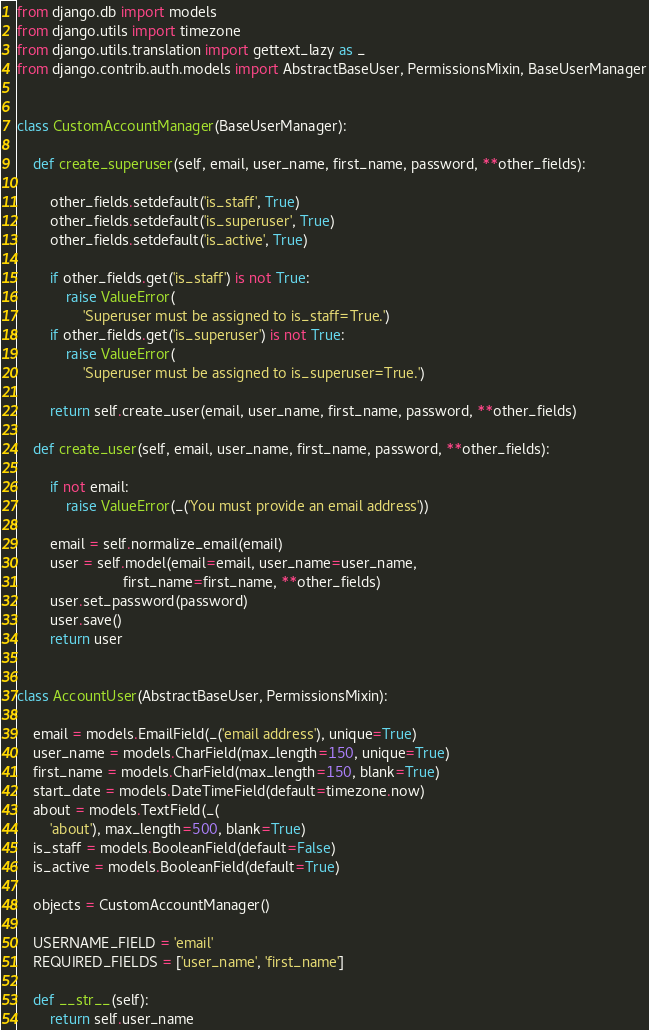<code> <loc_0><loc_0><loc_500><loc_500><_Python_>from django.db import models
from django.utils import timezone
from django.utils.translation import gettext_lazy as _
from django.contrib.auth.models import AbstractBaseUser, PermissionsMixin, BaseUserManager


class CustomAccountManager(BaseUserManager):

    def create_superuser(self, email, user_name, first_name, password, **other_fields):

        other_fields.setdefault('is_staff', True)
        other_fields.setdefault('is_superuser', True)
        other_fields.setdefault('is_active', True)

        if other_fields.get('is_staff') is not True:
            raise ValueError(
                'Superuser must be assigned to is_staff=True.')
        if other_fields.get('is_superuser') is not True:
            raise ValueError(
                'Superuser must be assigned to is_superuser=True.')

        return self.create_user(email, user_name, first_name, password, **other_fields)

    def create_user(self, email, user_name, first_name, password, **other_fields):

        if not email:
            raise ValueError(_('You must provide an email address'))

        email = self.normalize_email(email)
        user = self.model(email=email, user_name=user_name,
                          first_name=first_name, **other_fields)
        user.set_password(password)
        user.save()
        return user


class AccountUser(AbstractBaseUser, PermissionsMixin):

    email = models.EmailField(_('email address'), unique=True)
    user_name = models.CharField(max_length=150, unique=True)
    first_name = models.CharField(max_length=150, blank=True)
    start_date = models.DateTimeField(default=timezone.now)
    about = models.TextField(_(
        'about'), max_length=500, blank=True)
    is_staff = models.BooleanField(default=False)
    is_active = models.BooleanField(default=True)

    objects = CustomAccountManager()

    USERNAME_FIELD = 'email'
    REQUIRED_FIELDS = ['user_name', 'first_name']

    def __str__(self):
        return self.user_name</code> 